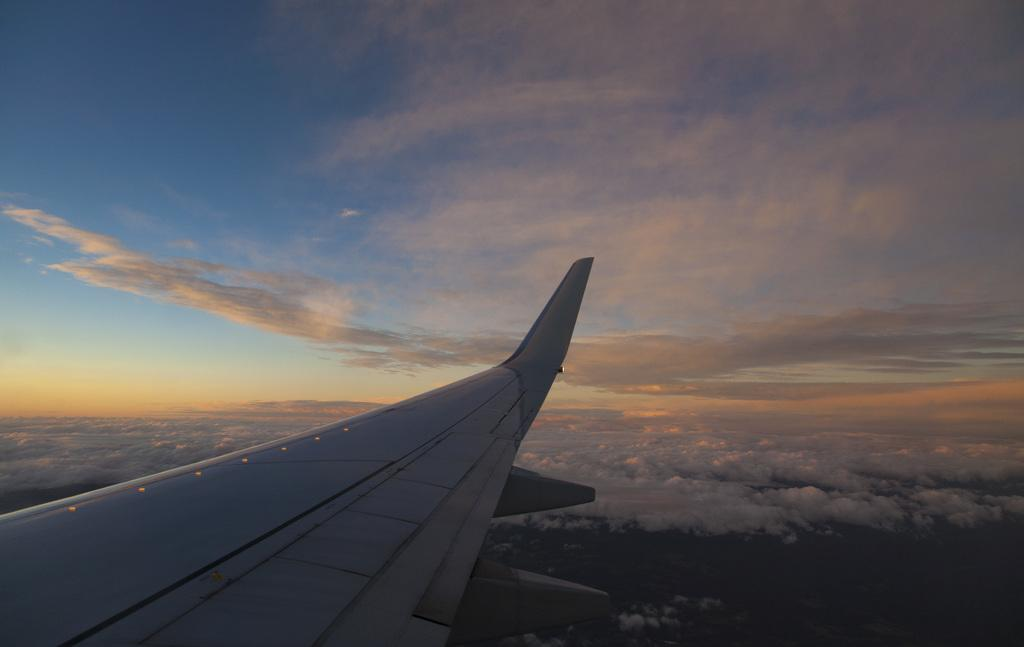What is the main subject of the image? The main subject of the image is a side wing of an aeroplane. What type of trail can be seen coming from the aeroplane in the image? There is no trail visible in the image; it only features a side wing of an aeroplane. What type of shame can be seen associated with the aeroplane in the image? There is no shame present in the image; it only features a side wing of an aeroplane. 